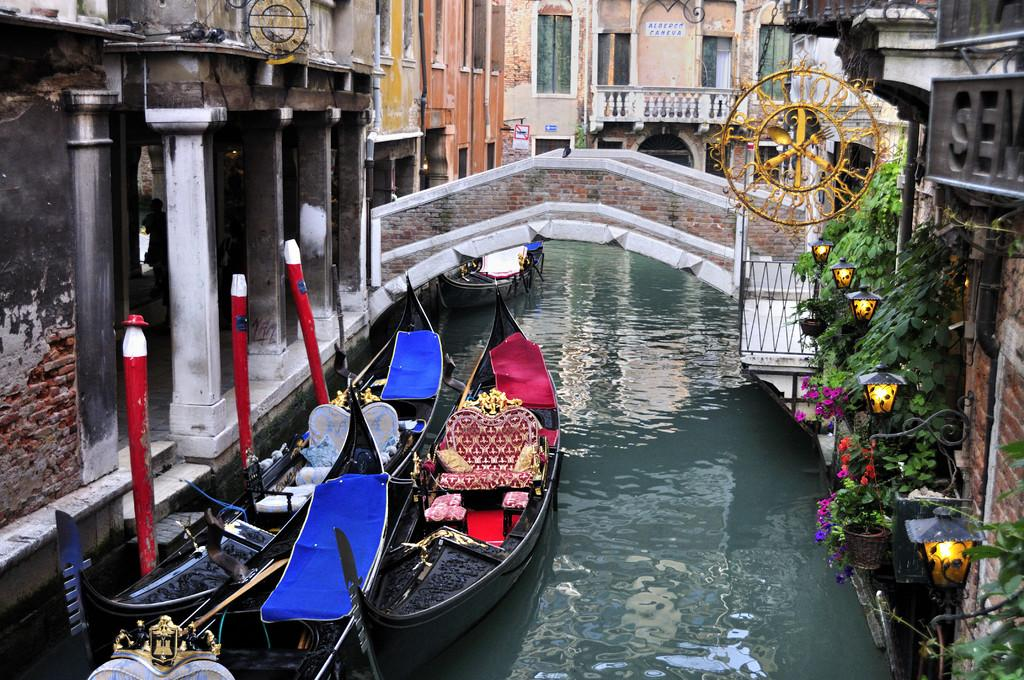What body of water is present in the image? There is a river in the image. What is on the river? There are boats on the river. How can people cross the river in the image? There is a bridge across the river. What type of structures are near the bridge? There are buildings and houses around the bridge. What type of riddle can be seen on the bridge in the image? There is no riddle present on the bridge in the image. What kind of wire is used to connect the boats in the image? There is no wire connecting the boats in the image; they are separate entities. 